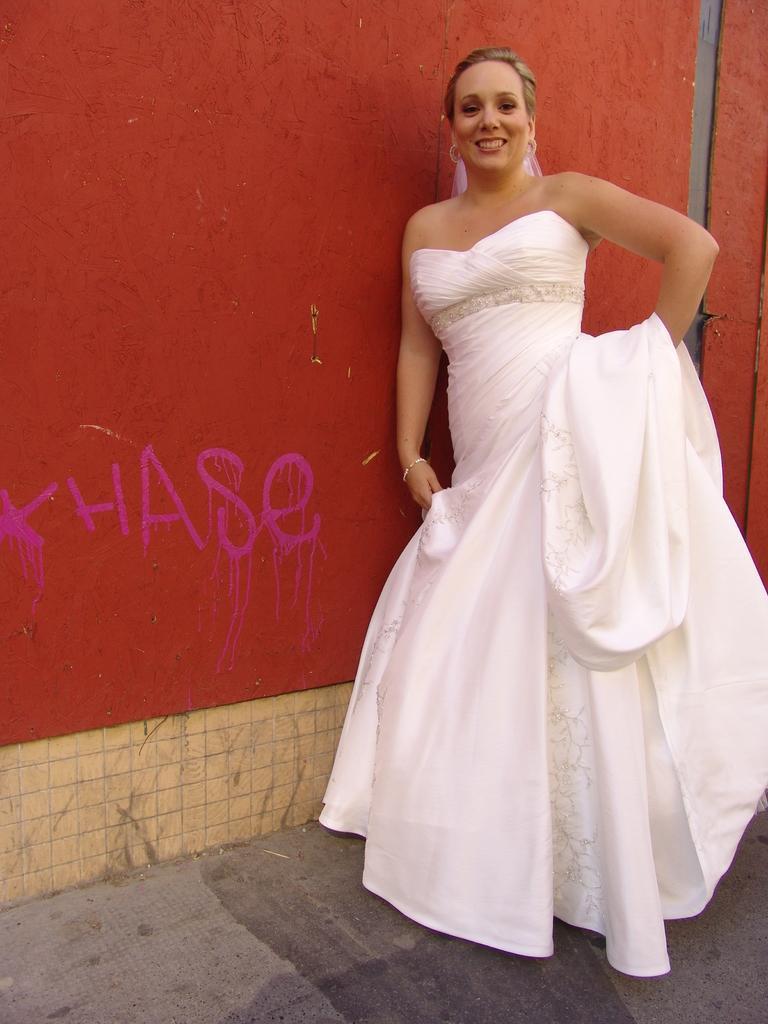Please provide a concise description of this image. In this image a woman wearing white color dress and standing near the wall. 